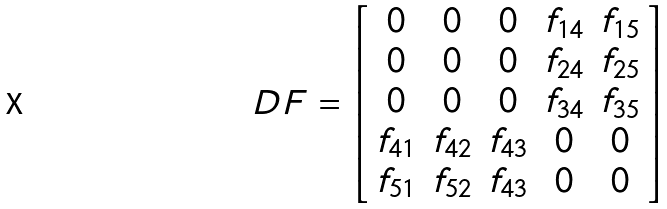<formula> <loc_0><loc_0><loc_500><loc_500>D F = \left [ \begin{array} { c c c c c } 0 & 0 & 0 & f _ { 1 4 } & f _ { 1 5 } \\ 0 & 0 & 0 & f _ { 2 4 } & f _ { 2 5 } \\ 0 & 0 & 0 & f _ { 3 4 } & f _ { 3 5 } \\ f _ { 4 1 } & f _ { 4 2 } & f _ { 4 3 } & 0 & 0 \\ f _ { 5 1 } & f _ { 5 2 } & f _ { 4 3 } & 0 & 0 \\ \end{array} \right ]</formula> 